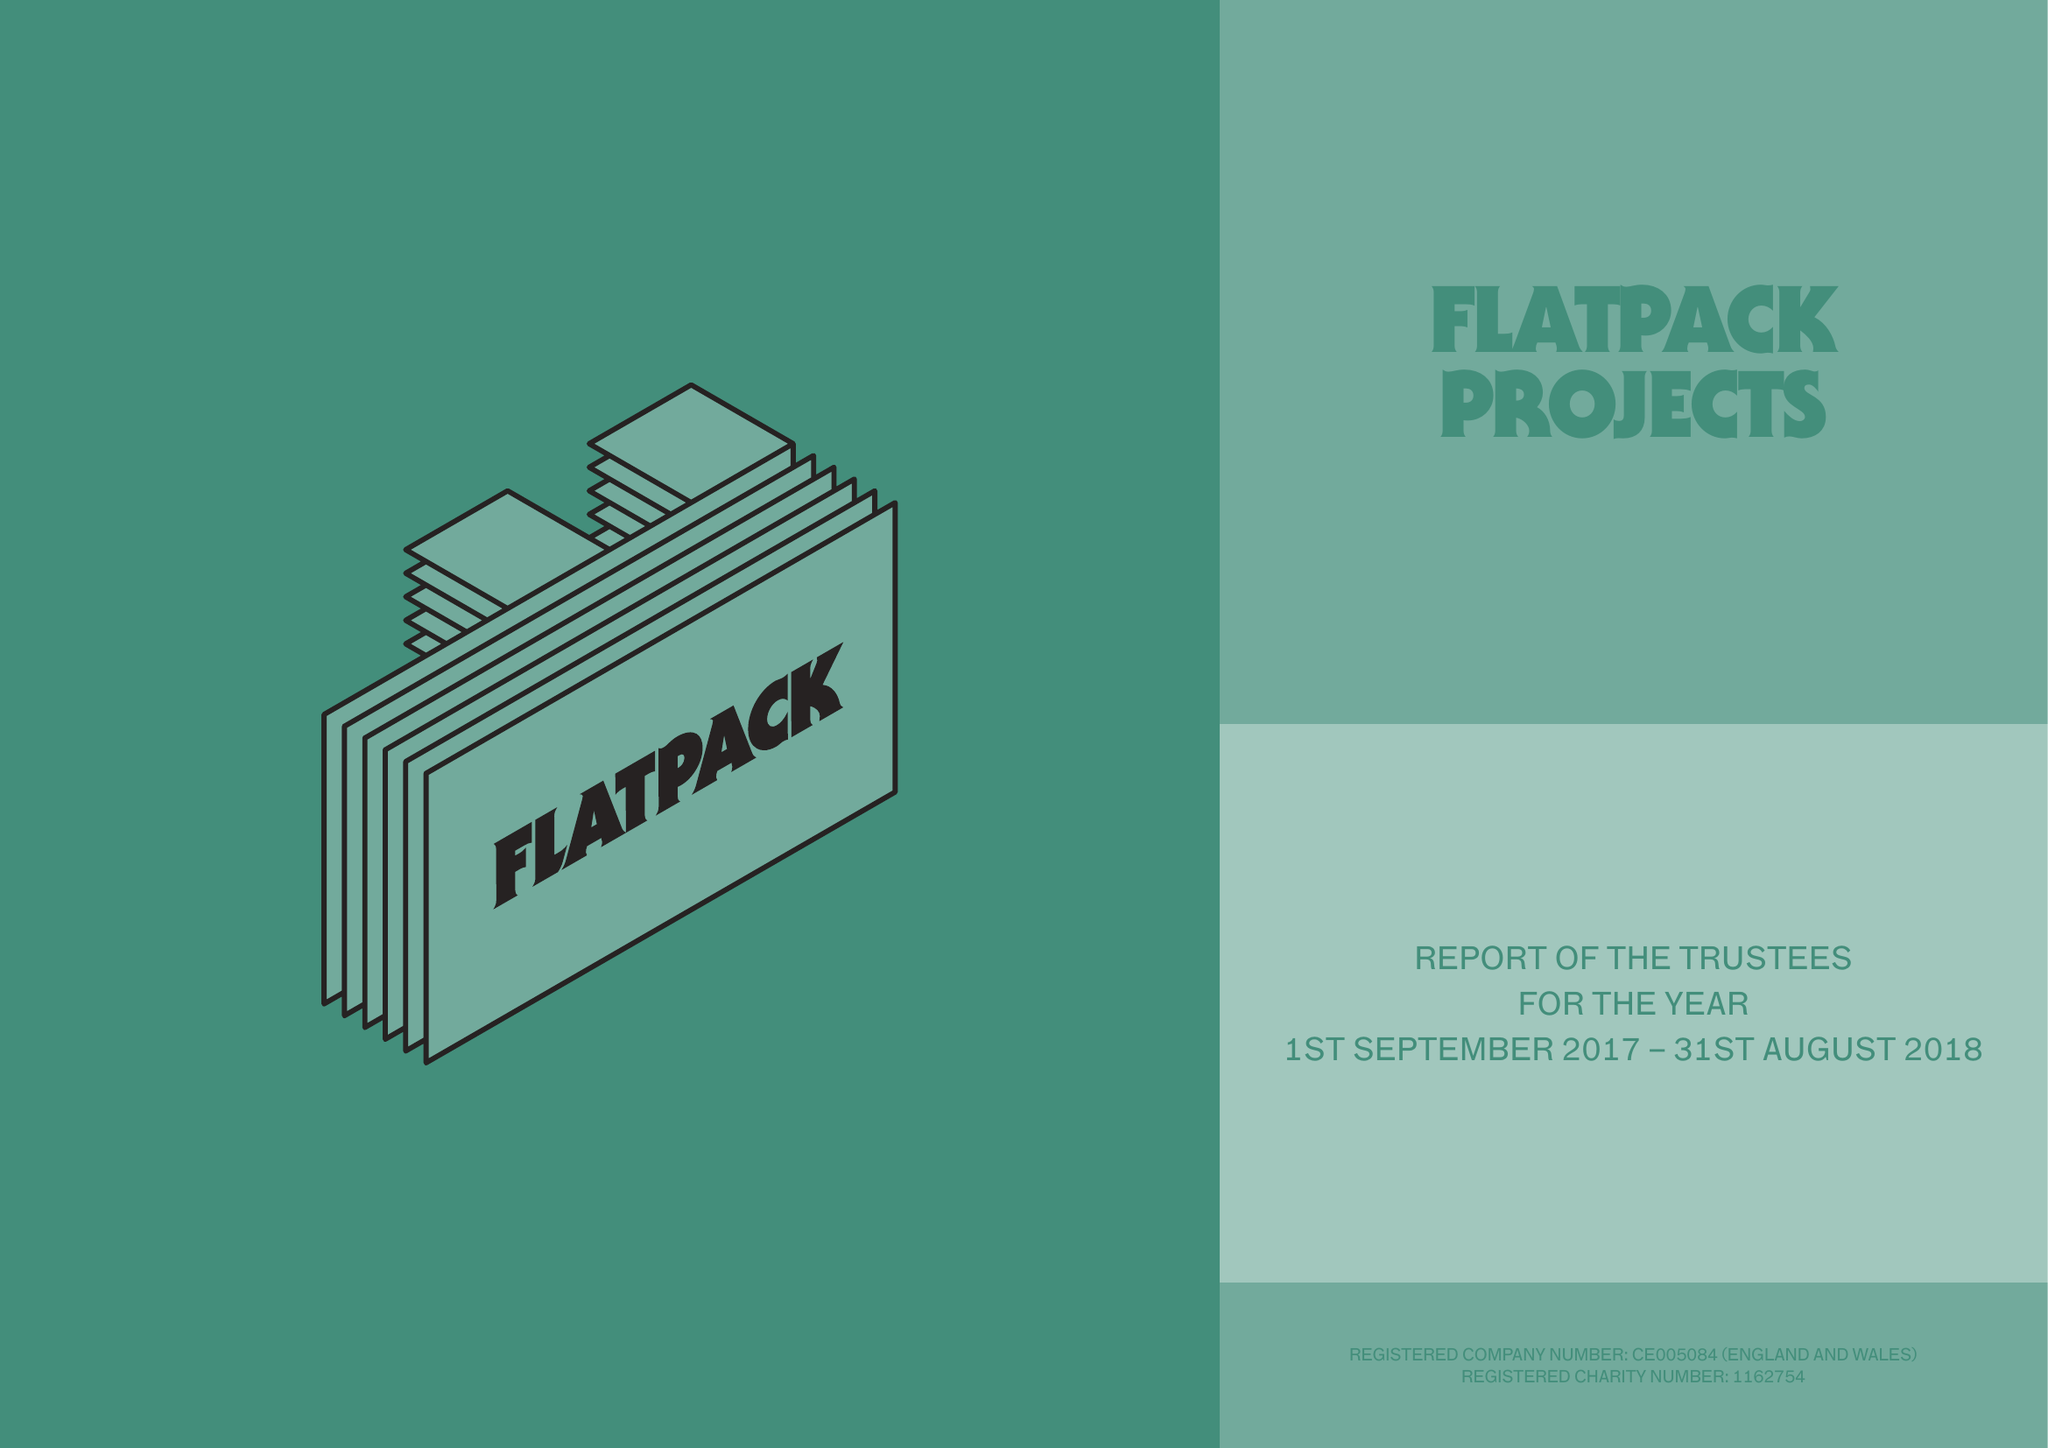What is the value for the address__street_line?
Answer the question using a single word or phrase. None 